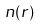<formula> <loc_0><loc_0><loc_500><loc_500>n ( r )</formula> 